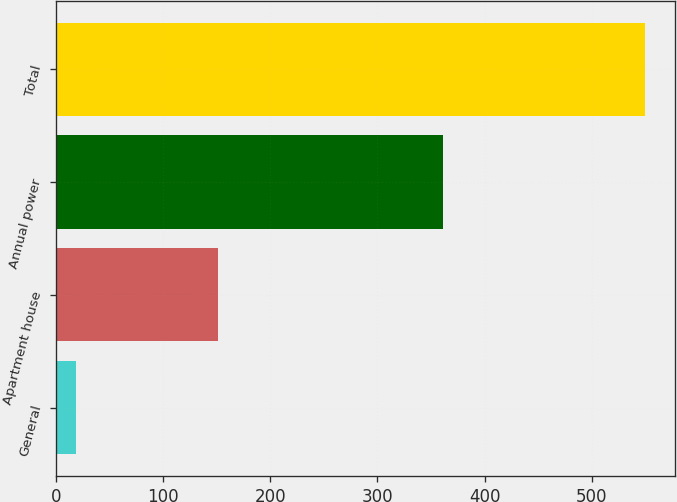<chart> <loc_0><loc_0><loc_500><loc_500><bar_chart><fcel>General<fcel>Apartment house<fcel>Annual power<fcel>Total<nl><fcel>19<fcel>151<fcel>361<fcel>550<nl></chart> 